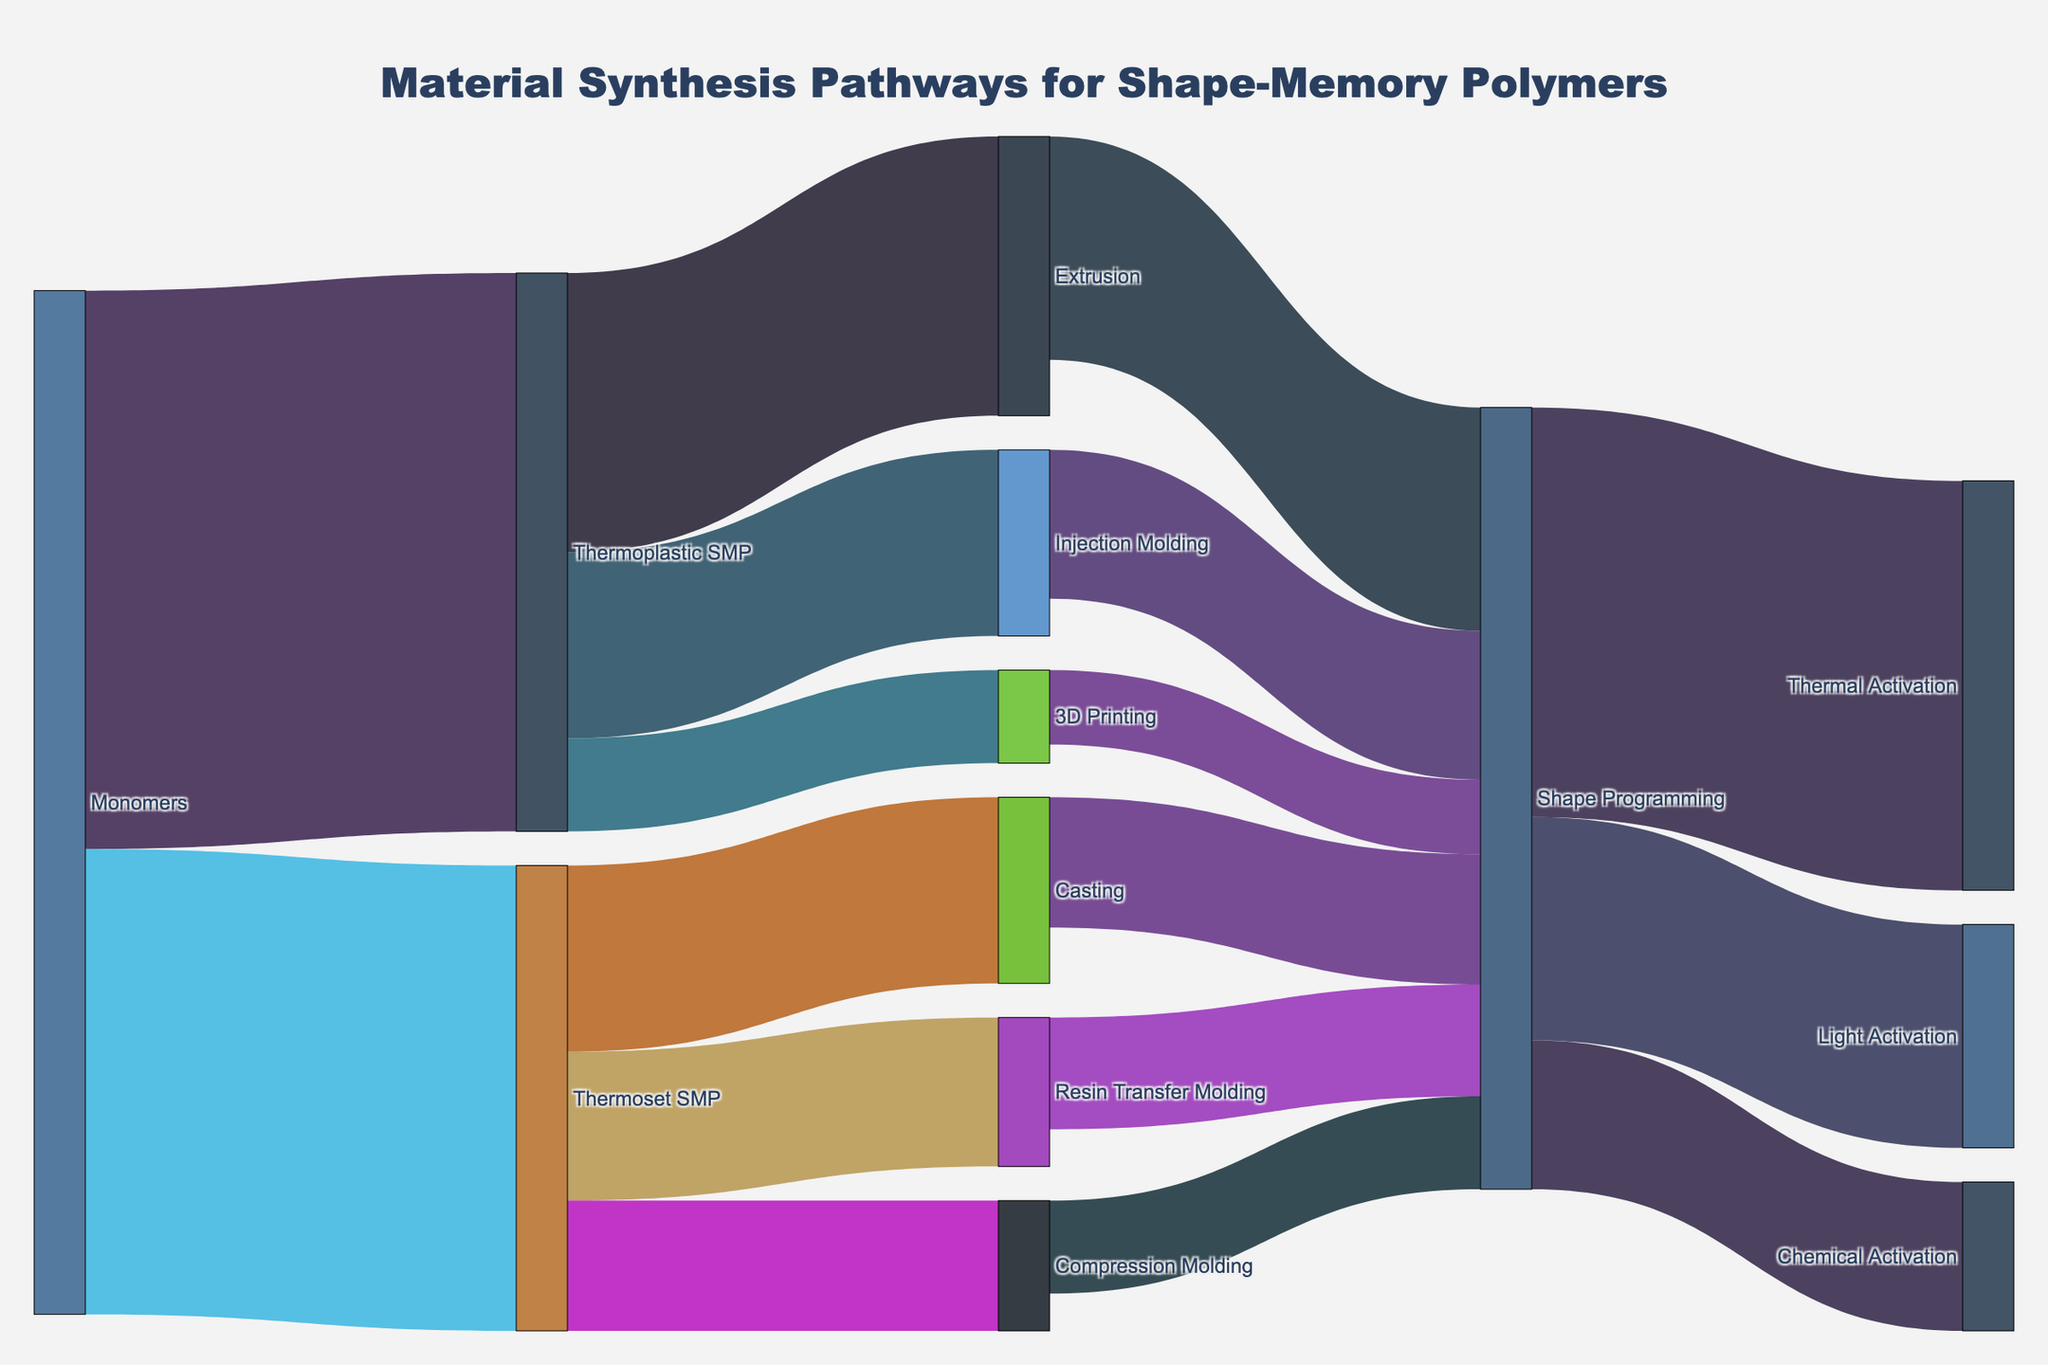what's the title of the figure? The title of the figure is located at the top center of the plot and it reads 'Material Synthesis Pathways for Shape-Memory Polymers'.
Answer: Material Synthesis Pathways for Shape-Memory Polymers How many pathways involve Thermoplastic SMP? First, identify all flows originating from Thermoplastic SMP. There are three: Extrusion, Injection Molding, and 3D Printing.
Answer: 3 Which process has the highest input from Monomers? Identify the flows originating from Monomers and compare their values. Thermoplastic SMP receives 30, and Thermoset SMP receives 25.
Answer: Thermoplastic SMP What is the total flow value into Shape Programming? Sum the values of all pathways leading into Shape Programming: Extrusion (12) + Injection Molding (8) + 3D Printing (4) + Casting (7) + Resin Transfer Molding (6) + Compression Molding (5) == total of 42.
Answer: 42 Which activation method has the highest flow value in the figure? Look at the flows originating from Shape Programming: Thermal Activation (22), Light Activation (12), Chemical Activation (8). Thermal Activation has the highest value.
Answer: Thermal Activation What is the combined flow value from Thermoplastics and Thermosets SMP to Shape Programming? Add the values of pathways from Thermoplastics and Thermosets SMP to Shape Programming. From Thermoplastics SMP: Extrusion (12) + Injection Molding (8) + 3D Printing (4) = 24. From Thermosets SMP: Casting (7) + Resin Transfer Molding (6) + Compression Molding (5) = 18. Total is 24 + 18 = 42.
Answer: 42 Which material synthesis process relies more on Injection Molding than Thermoset SMP processes? Identify pathways from Injection Molding and compare their values to those from Thermoset SMP: Injection Molding to Shape Programming (8) is higher than Compression Molding to Shape Programming (5).
Answer: Injection Molding to Shape Programming What is the total number of distinct nodes in the diagram? Count the unique labels listed in the nodes, including Monomers, various SMPs, molding processes, shape programming, and activation methods. There are 12 unique nodes.
Answer: 12 